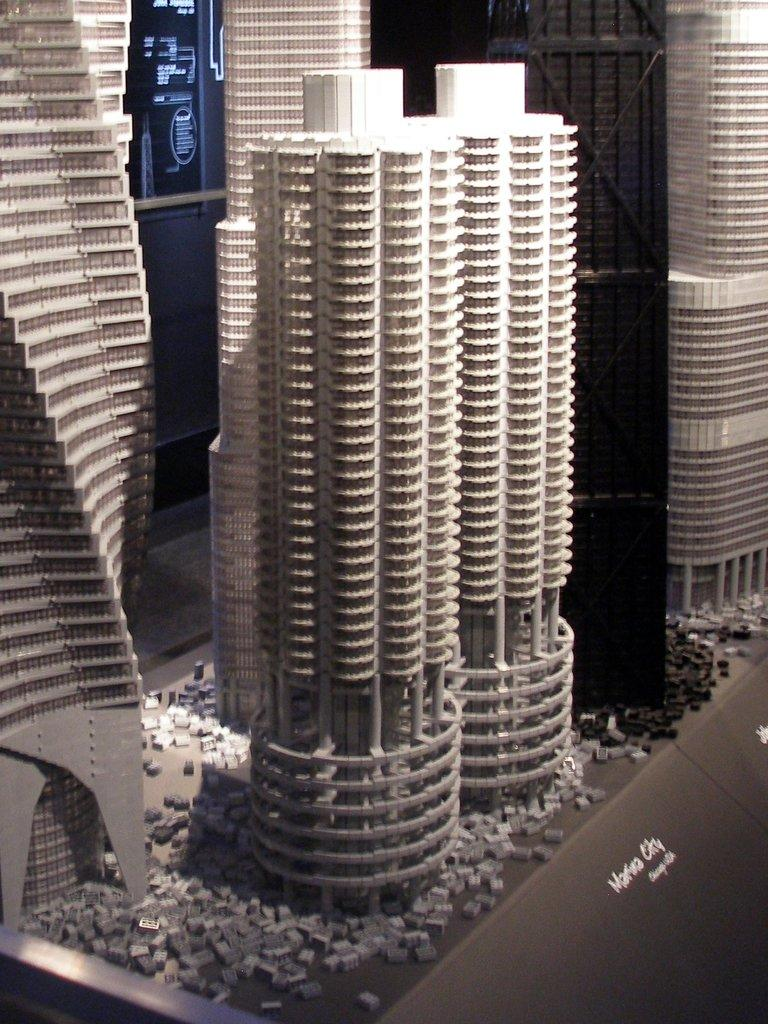What is the main subject of the image? The main subject of the image is models of buildings. Where are the models of buildings located in the image? The models of buildings are in the middle of the image. Is there any text present in the image? Yes, there is text written in the bottom right corner of the image. What type of thunder can be heard in the image? There is no sound, including thunder, present in the image. What color is the flag flying above the models of buildings in the image? There is no flag present in the image. 